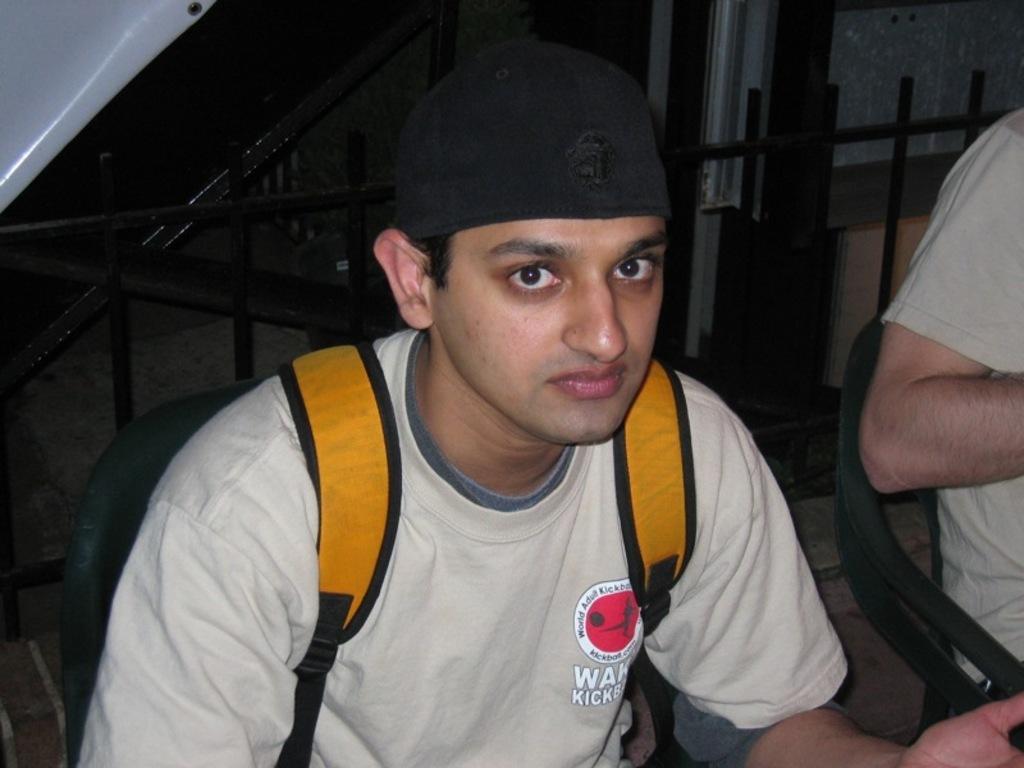In one or two sentences, can you explain what this image depicts? In this image I can see two persons sitting. In front the person is wearing cream color shirt and an orange color bag, background I can see the railing. 